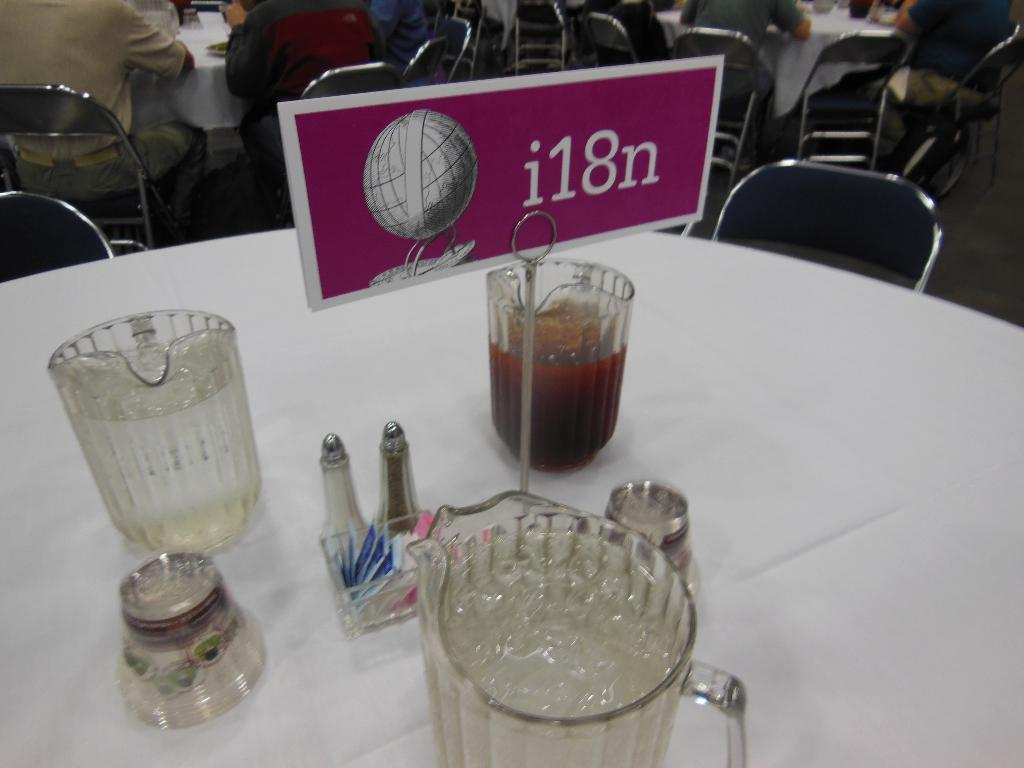<image>
Offer a succinct explanation of the picture presented. A tablecloth and place settings with "i18n" shown on the place card. 